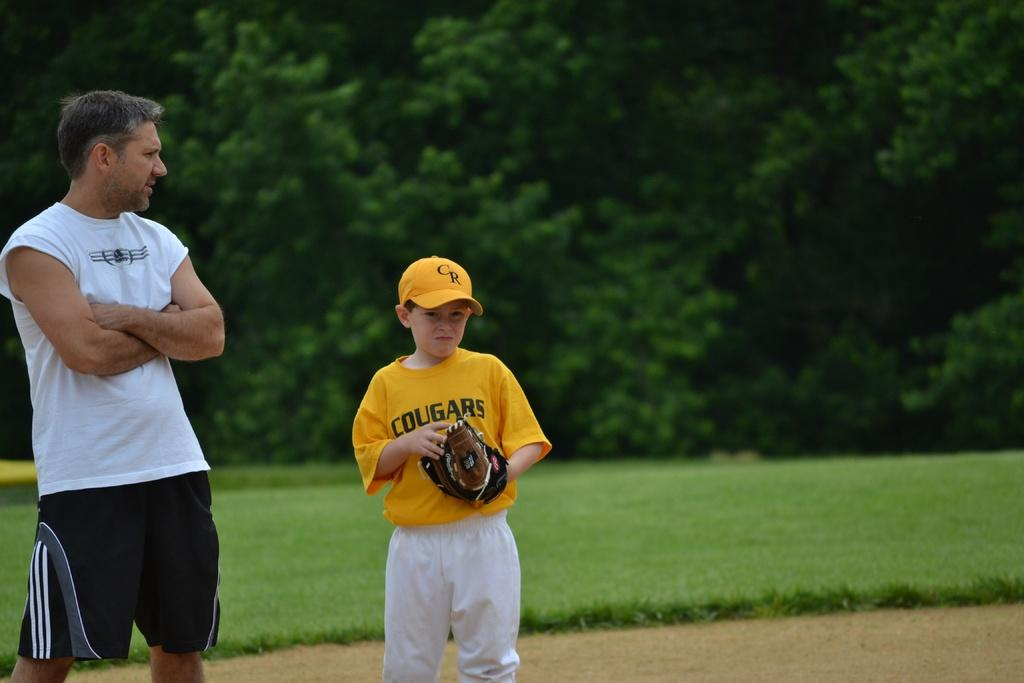<image>
Create a compact narrative representing the image presented. A young boy in a cougars jersey is wearing a baseball glove. 